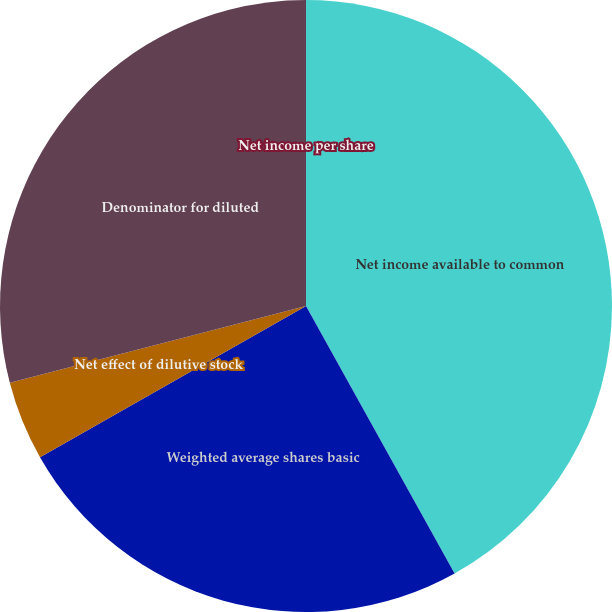Convert chart to OTSL. <chart><loc_0><loc_0><loc_500><loc_500><pie_chart><fcel>Net income available to common<fcel>Weighted average shares basic<fcel>Net effect of dilutive stock<fcel>Denominator for diluted<fcel>Net income per share<nl><fcel>41.93%<fcel>24.84%<fcel>4.19%<fcel>29.04%<fcel>0.0%<nl></chart> 